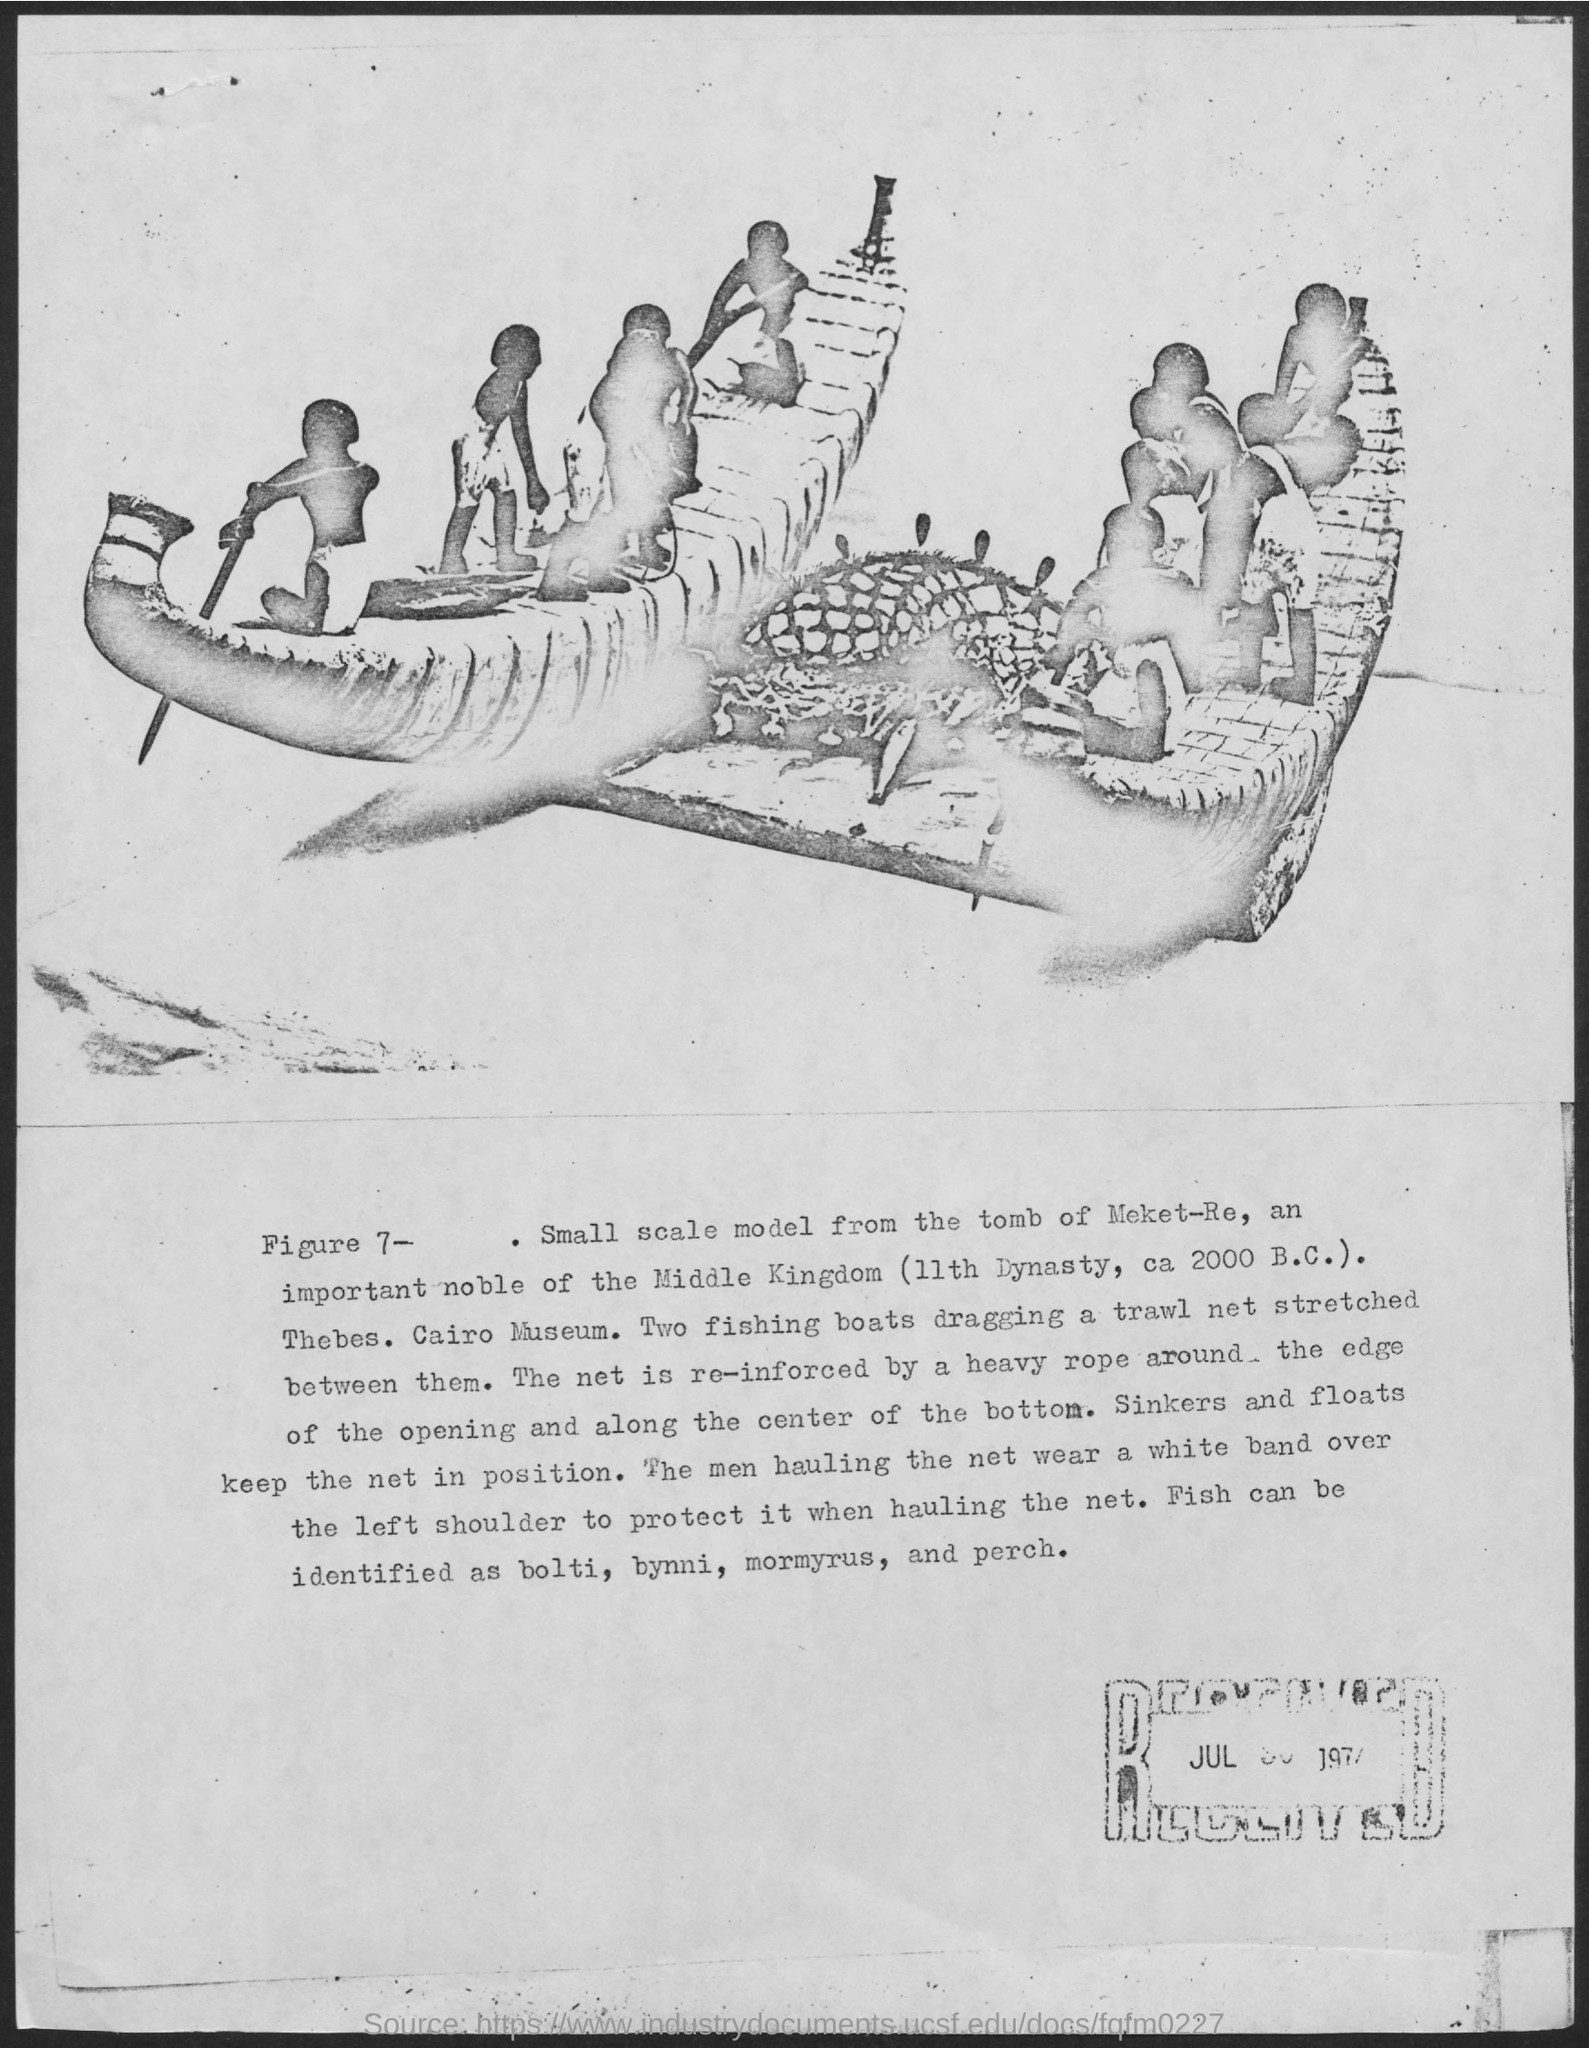What is the number of Figure?
Make the answer very short. Figure 7. 